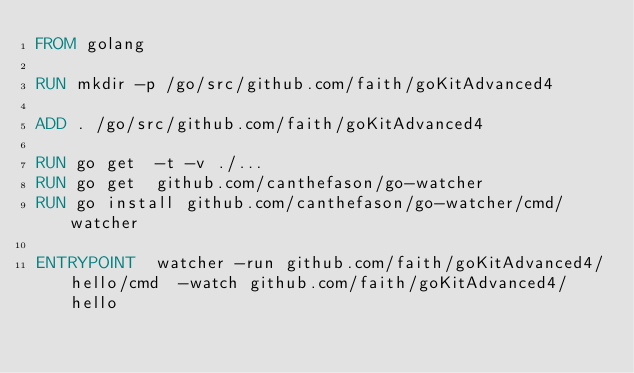Convert code to text. <code><loc_0><loc_0><loc_500><loc_500><_Dockerfile_>FROM golang

RUN mkdir -p /go/src/github.com/faith/goKitAdvanced4

ADD . /go/src/github.com/faith/goKitAdvanced4

RUN go get  -t -v ./...
RUN go get  github.com/canthefason/go-watcher
RUN go install github.com/canthefason/go-watcher/cmd/watcher

ENTRYPOINT  watcher -run github.com/faith/goKitAdvanced4/hello/cmd  -watch github.com/faith/goKitAdvanced4/hello
</code> 